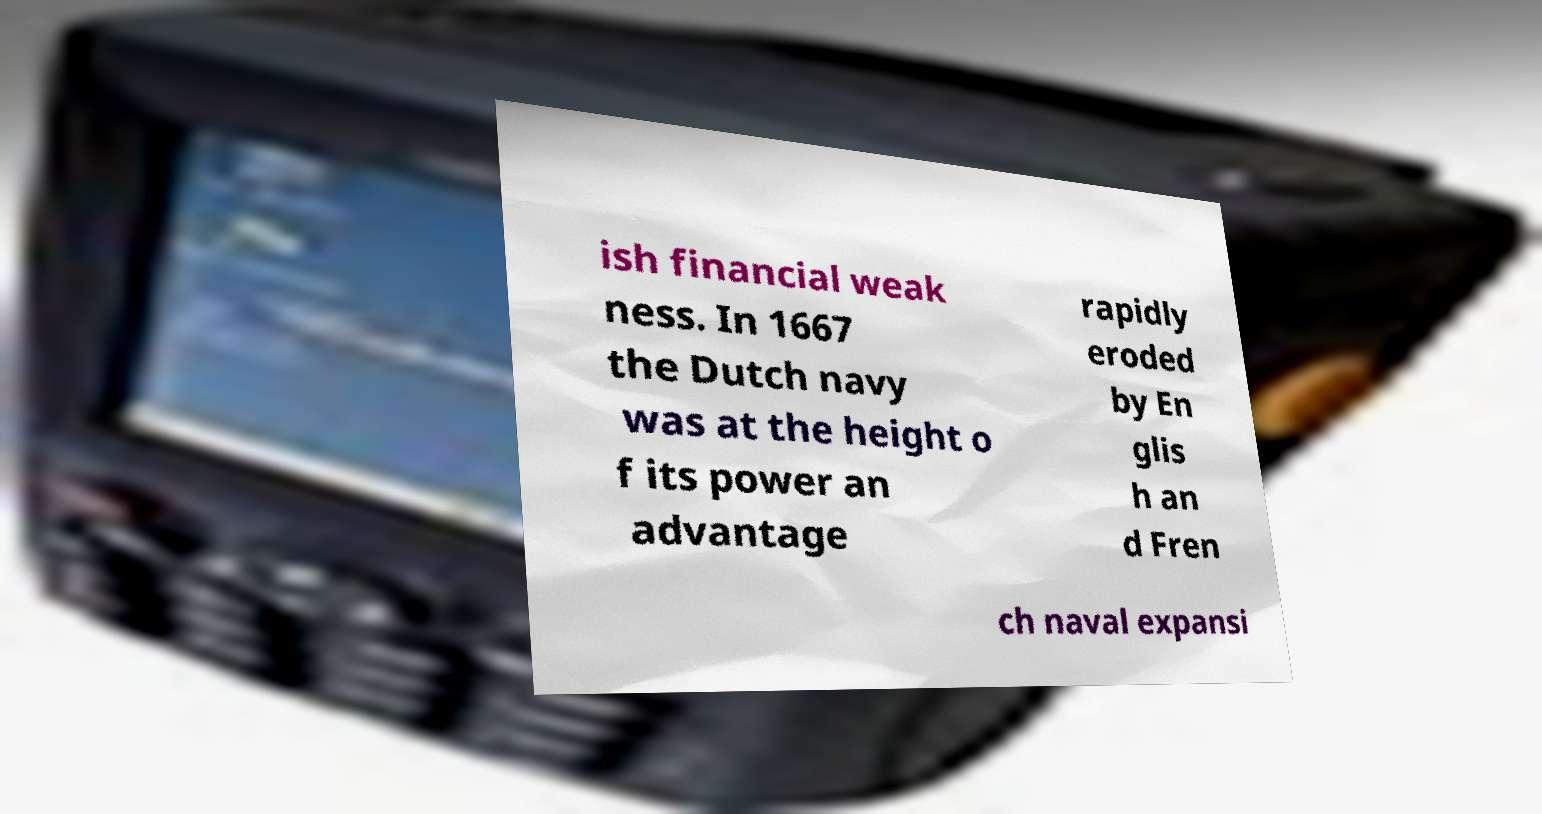Could you assist in decoding the text presented in this image and type it out clearly? ish financial weak ness. In 1667 the Dutch navy was at the height o f its power an advantage rapidly eroded by En glis h an d Fren ch naval expansi 